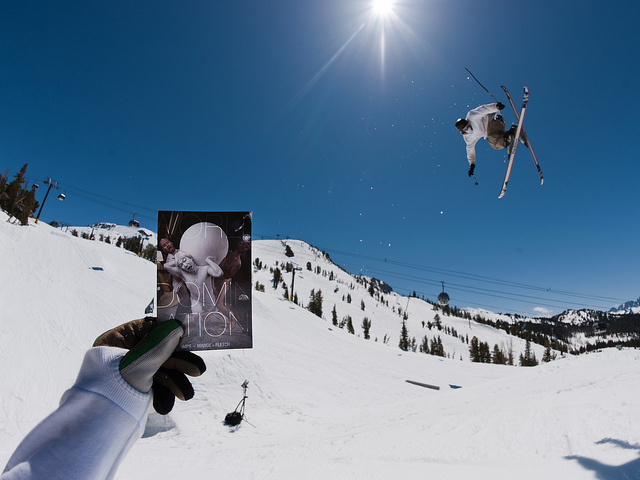Identify the text contained in this image. DOM TION 